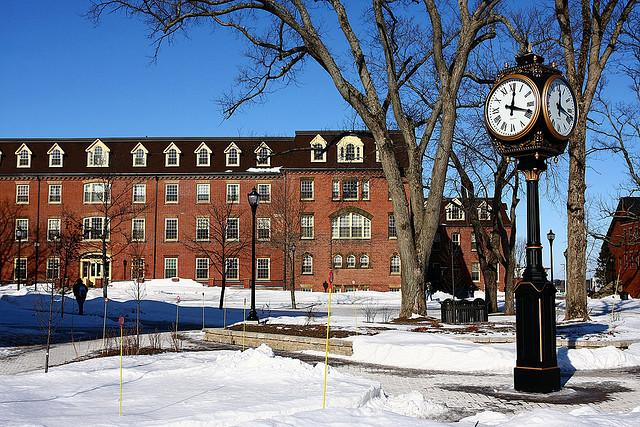What is the coldest place in the area? ground 